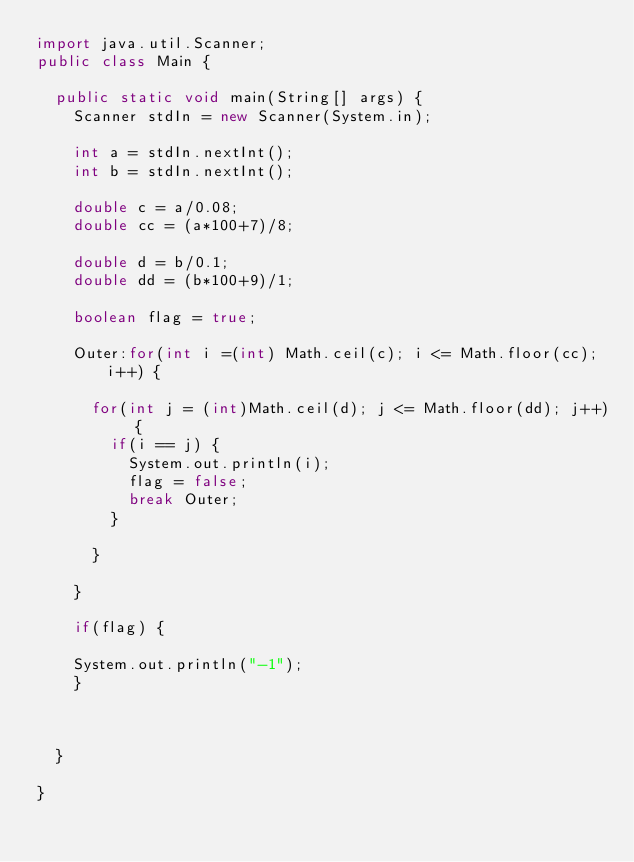<code> <loc_0><loc_0><loc_500><loc_500><_Java_>import java.util.Scanner;
public class Main {

	public static void main(String[] args) {
		Scanner stdIn = new Scanner(System.in);

		int a = stdIn.nextInt();
		int b = stdIn.nextInt();
		
		double c = a/0.08;
		double cc = (a*100+7)/8;

		double d = b/0.1;
		double dd = (b*100+9)/1;
		
		boolean flag = true;
		
		Outer:for(int i =(int) Math.ceil(c); i <= Math.floor(cc); i++) {
			
			for(int j = (int)Math.ceil(d); j <= Math.floor(dd); j++) {
				if(i == j) {
					System.out.println(i);
					flag = false;
					break Outer;
				}
				
			}
			
		}
		
		if(flag) {
			
		System.out.println("-1");
		}
		
		

	}

}
</code> 